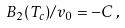<formula> <loc_0><loc_0><loc_500><loc_500>B _ { 2 } ( T _ { c } ) / v _ { 0 } = - C \, ,</formula> 